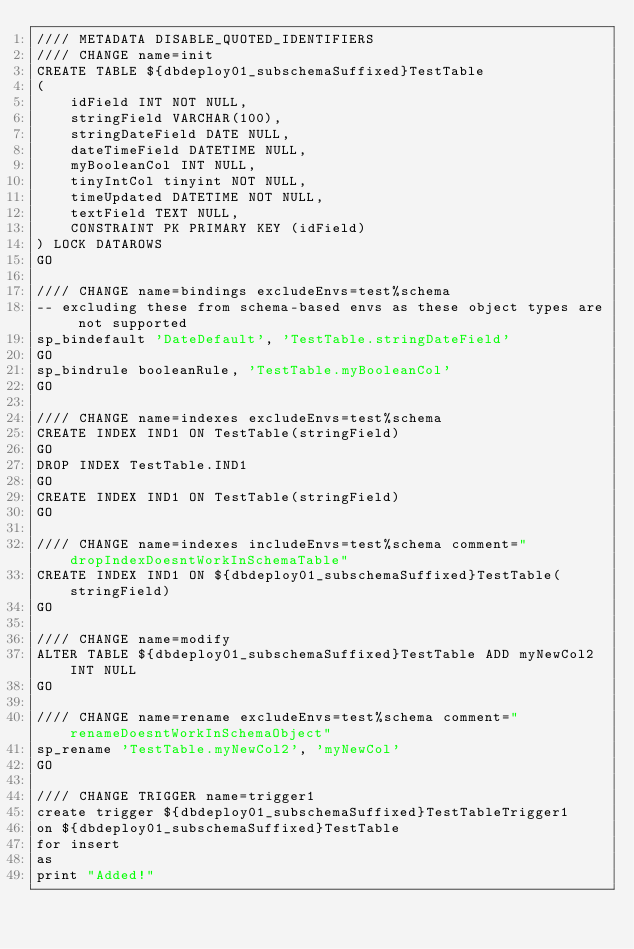<code> <loc_0><loc_0><loc_500><loc_500><_SQL_>//// METADATA DISABLE_QUOTED_IDENTIFIERS
//// CHANGE name=init
CREATE TABLE ${dbdeploy01_subschemaSuffixed}TestTable
(
	idField INT NOT NULL,
	stringField VARCHAR(100),
	stringDateField DATE NULL,
	dateTimeField DATETIME NULL,
	myBooleanCol INT NULL,
	tinyIntCol tinyint NOT NULL,
	timeUpdated DATETIME NOT NULL,
	textField TEXT NULL,
	CONSTRAINT PK PRIMARY KEY (idField)
) LOCK DATAROWS
GO

//// CHANGE name=bindings excludeEnvs=test%schema
-- excluding these from schema-based envs as these object types are not supported
sp_bindefault 'DateDefault', 'TestTable.stringDateField'
GO
sp_bindrule booleanRule, 'TestTable.myBooleanCol'
GO

//// CHANGE name=indexes excludeEnvs=test%schema
CREATE INDEX IND1 ON TestTable(stringField)
GO
DROP INDEX TestTable.IND1
GO
CREATE INDEX IND1 ON TestTable(stringField)
GO

//// CHANGE name=indexes includeEnvs=test%schema comment="dropIndexDoesntWorkInSchemaTable"
CREATE INDEX IND1 ON ${dbdeploy01_subschemaSuffixed}TestTable(stringField)
GO

//// CHANGE name=modify
ALTER TABLE ${dbdeploy01_subschemaSuffixed}TestTable ADD myNewCol2 INT NULL
GO

//// CHANGE name=rename excludeEnvs=test%schema comment="renameDoesntWorkInSchemaObject"
sp_rename 'TestTable.myNewCol2', 'myNewCol'
GO

//// CHANGE TRIGGER name=trigger1
create trigger ${dbdeploy01_subschemaSuffixed}TestTableTrigger1
on ${dbdeploy01_subschemaSuffixed}TestTable
for insert
as
print "Added!"
</code> 